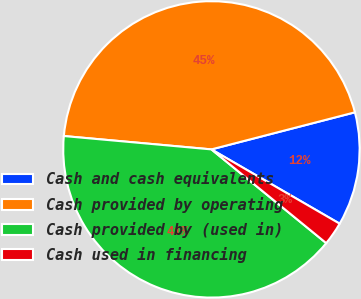Convert chart to OTSL. <chart><loc_0><loc_0><loc_500><loc_500><pie_chart><fcel>Cash and cash equivalents<fcel>Cash provided by operating<fcel>Cash provided by (used in)<fcel>Cash used in financing<nl><fcel>12.38%<fcel>44.54%<fcel>40.54%<fcel>2.54%<nl></chart> 